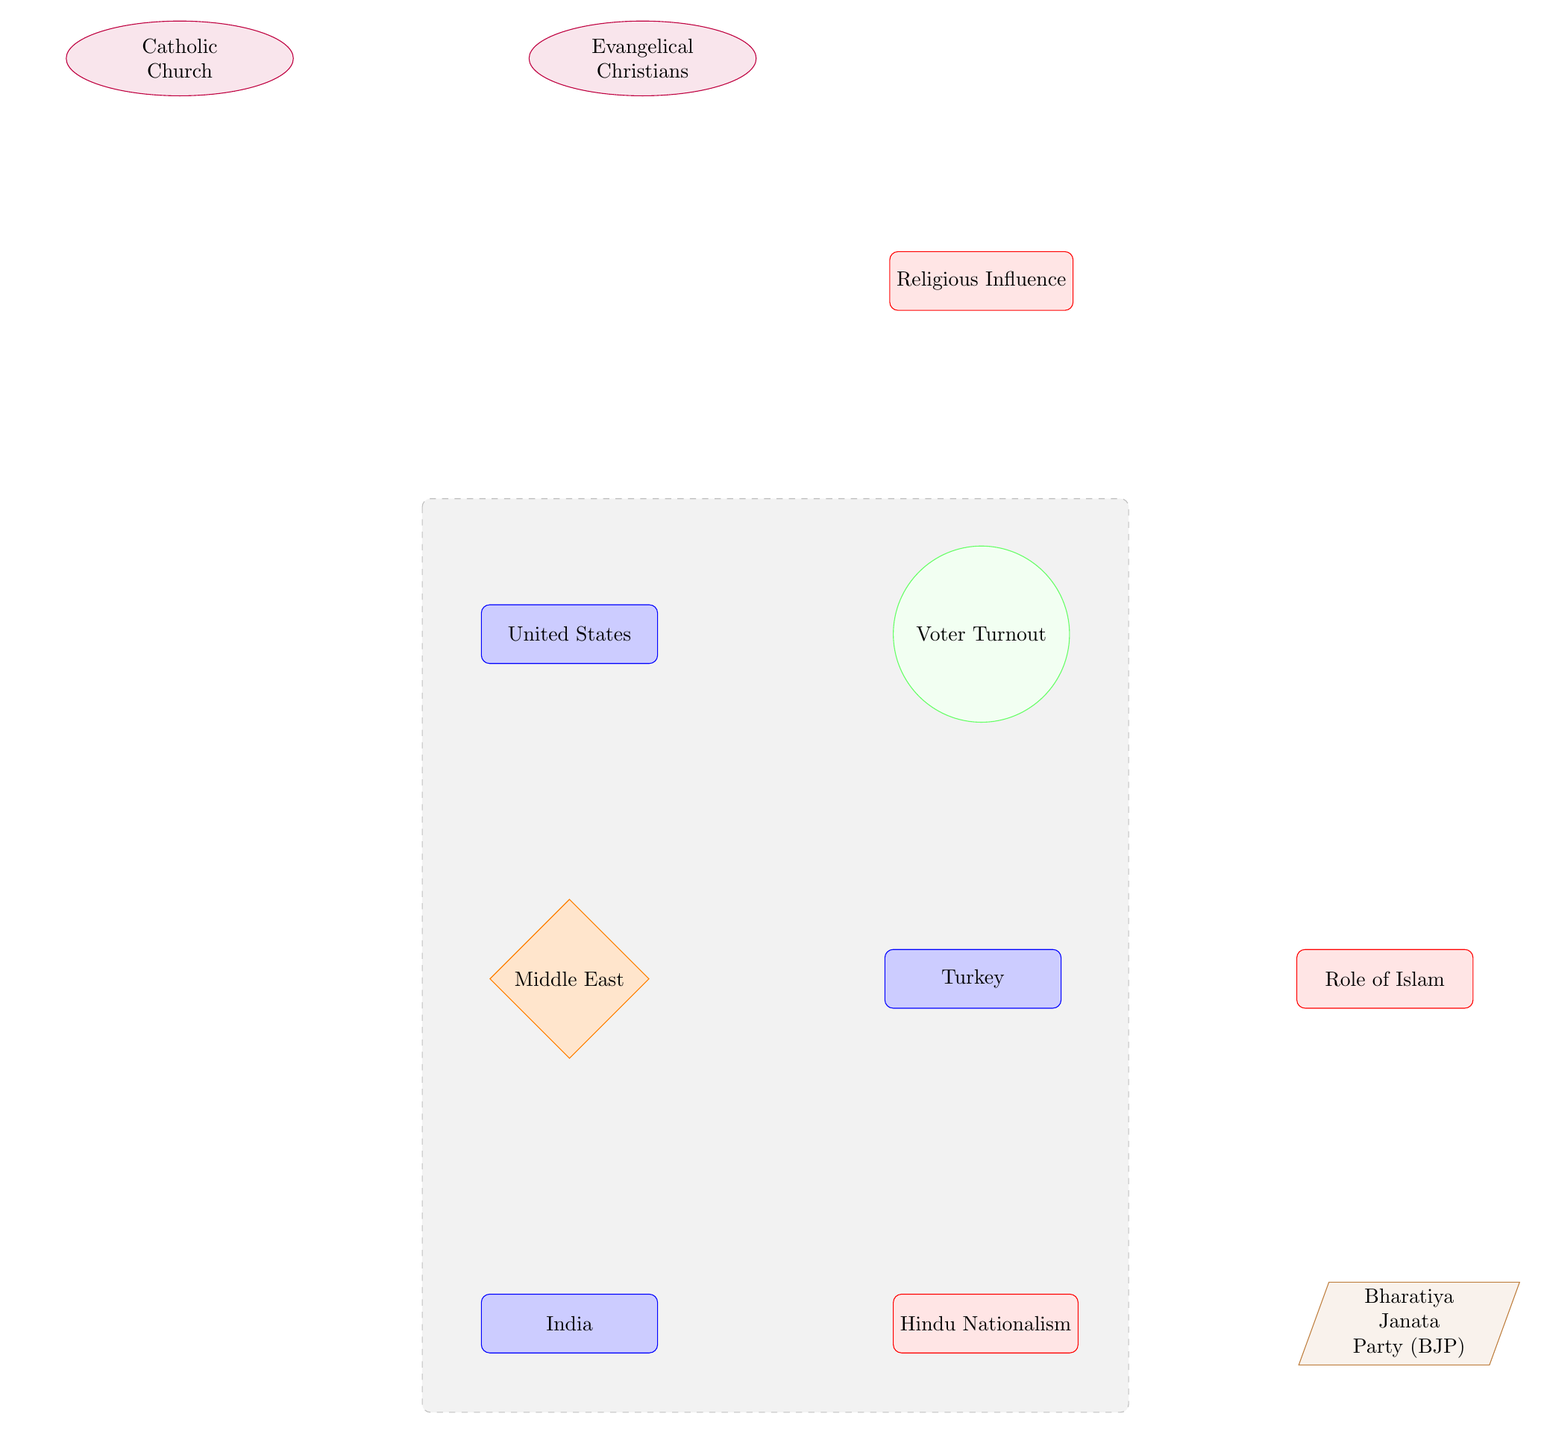What countries are shown in the diagram? The diagram shows three countries: the United States, Turkey, and India, all of which are directly represented as "country" nodes.
Answer: United States, Turkey, India What type of influence is represented in relation to the United States? The influence related to the United States is labeled "Religious Influence," indicating that religious factors are affecting outcomes such as voter turnout.
Answer: Religious Influence How many religious groups are shown for the United States? The diagram identifies two religious groups influencing voter turnout in the United States: Evangelical Christians and the Catholic Church.
Answer: 2 What is the arrow's direction from "Evangelical Christians" to "Religious Influence"? The arrow illustrates a clear directional influence moving from "Evangelical Christians" towards the "Religious Influence," demonstrating that this group plays a role in shaping the religious influence.
Answer: From left to right What is the relationship between "Bharatiya Janata Party (BJP)" and "Voter Turnout"? The "Bharatiya Janata Party (BJP)" directly influences "Voter Turnout" in India, as shown by the arrow from the BJP leading to the voter turnout outcome node.
Answer: Direct influence How does "Role of Islam" impact "Voter Turnout"? "Role of Islam" influences "Voter Turnout" in Turkey, with an arrow directing from "Role of Islam" to "Voter Turnout," indicating that Islam plays a significant role in the voter participation rates in that country.
Answer: Through direct influence What is the flow of influence from "Hindu Nationalism"? The diagram illustrates that "Hindu Nationalism" influences both the "Bharatiya Janata Party (BJP)" and subsequently the "Voter Turnout," reflecting a two-step flow from Hindu Nationalism to BJP, then to voter turnout.
Answer: Two-step flow Which node is affected by both the "Catholic Church" and "Evangelical Christians"? The node affected by both the "Catholic Church" and "Evangelical Christians" is "Religious Influence," which is shaped by these two religious groups before affecting voter turnout.
Answer: Religious Influence 